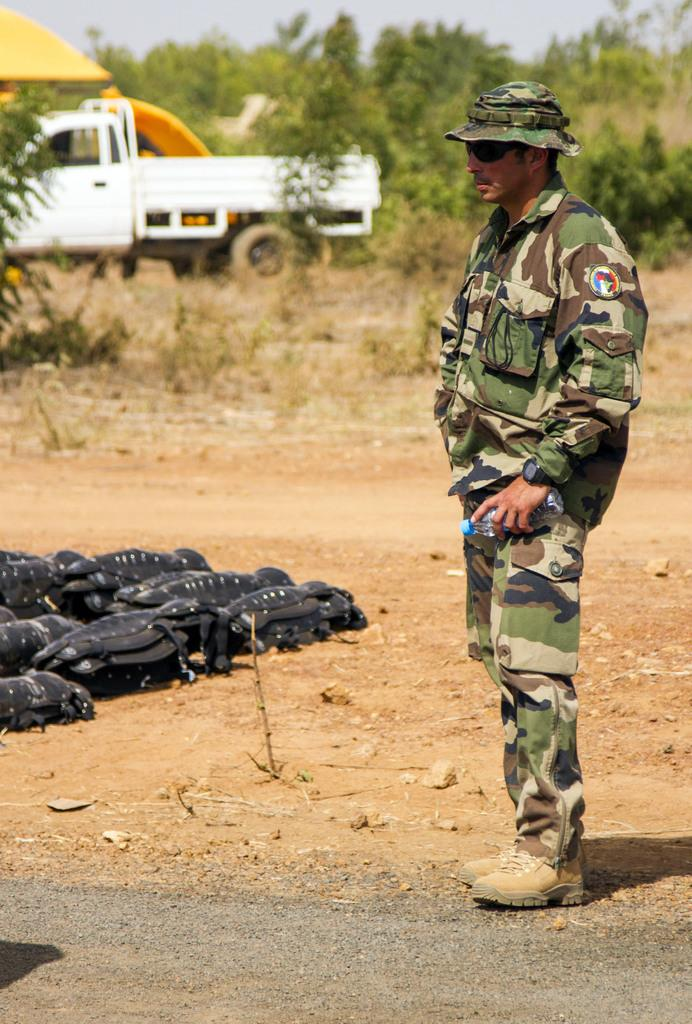What is the main subject of the image? There is a soldier standing in the image. Where is the soldier positioned in relation to the ground? The soldier is standing on the ground. What can be seen in front of the soldier? There are objects in front of the soldier. What is visible in the background of the image? There is a truck in the background of the image. What type of vegetation is behind the truck? There are trees behind the truck. What type of verse can be heard being recited by the soldier in the image? There is no indication in the image that the soldier is reciting a verse, so it cannot be determined from the image. 